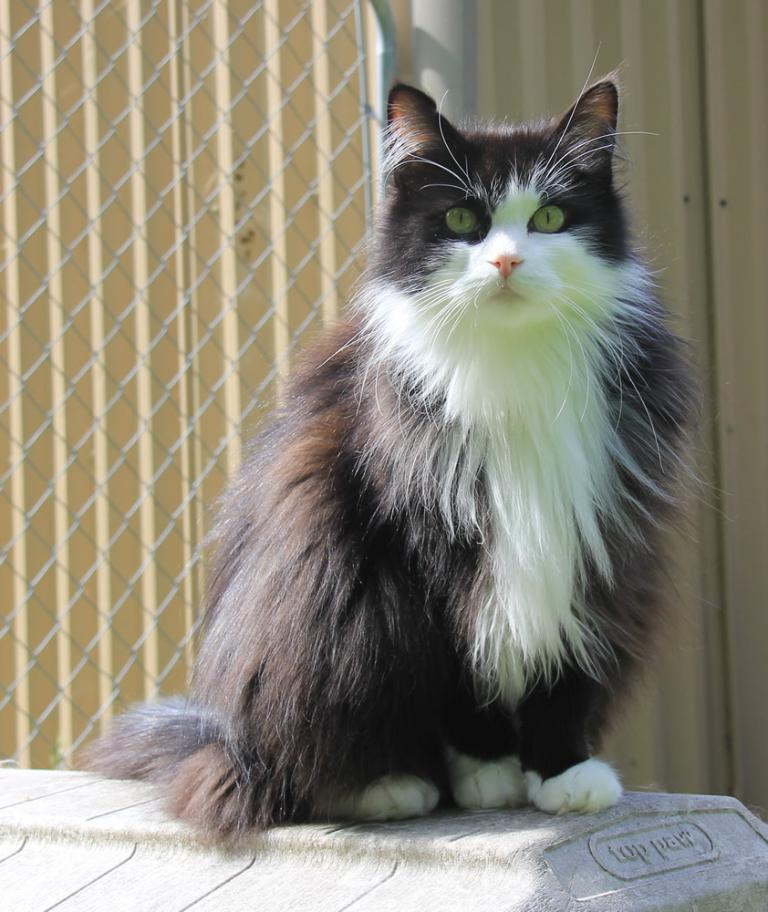What animal can be seen in the image? There is a cat in the image. Where is the cat located? The cat is sitting on a wall. What is written or drawn on the wall? There is text on the wall. What type of barrier can be seen in the image? There is a fence visible in the image. Are the cat's teeth visible in the image? The cat's teeth are not visible in the image. Is there a volcano erupting in the background of the image? There is no volcano present in the image. 